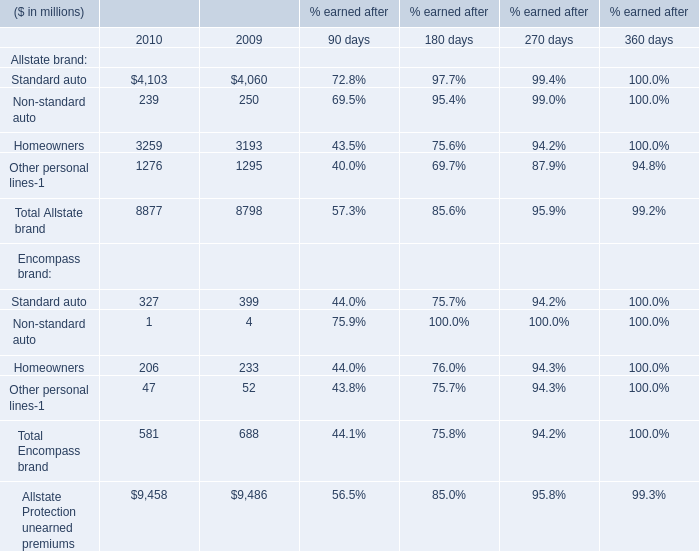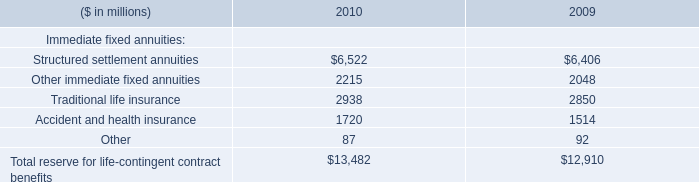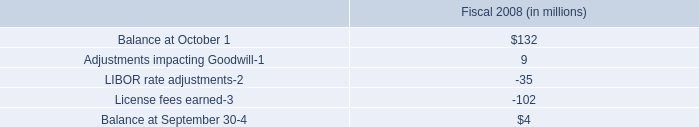What is the ratio of Standard auto of Allstate brand to the total in 2010? 
Computations: (4103 / 9458)
Answer: 0.43381. 